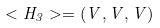Convert formula to latex. <formula><loc_0><loc_0><loc_500><loc_500>< H _ { 3 } > = ( V , V , V )</formula> 